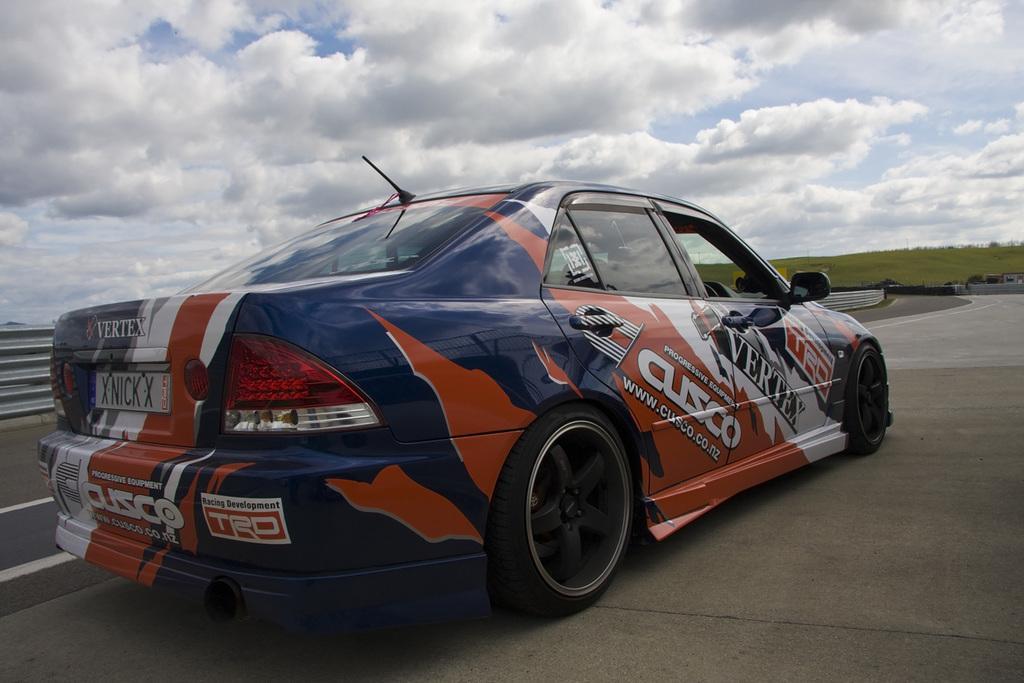Could you give a brief overview of what you see in this image? In this picture, we can see a vehicle, road, ground with grass, some object on the left side of the picture, we can see the sky with clouds. 